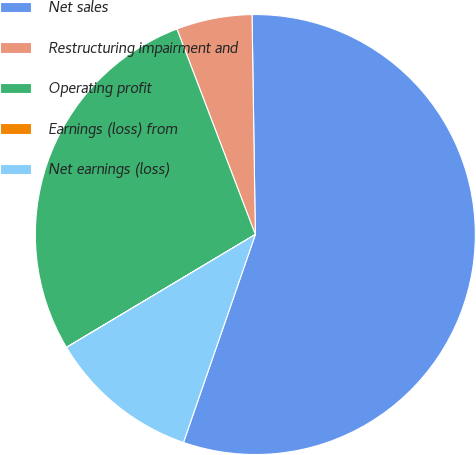Convert chart. <chart><loc_0><loc_0><loc_500><loc_500><pie_chart><fcel>Net sales<fcel>Restructuring impairment and<fcel>Operating profit<fcel>Earnings (loss) from<fcel>Net earnings (loss)<nl><fcel>55.53%<fcel>5.56%<fcel>27.77%<fcel>0.01%<fcel>11.12%<nl></chart> 